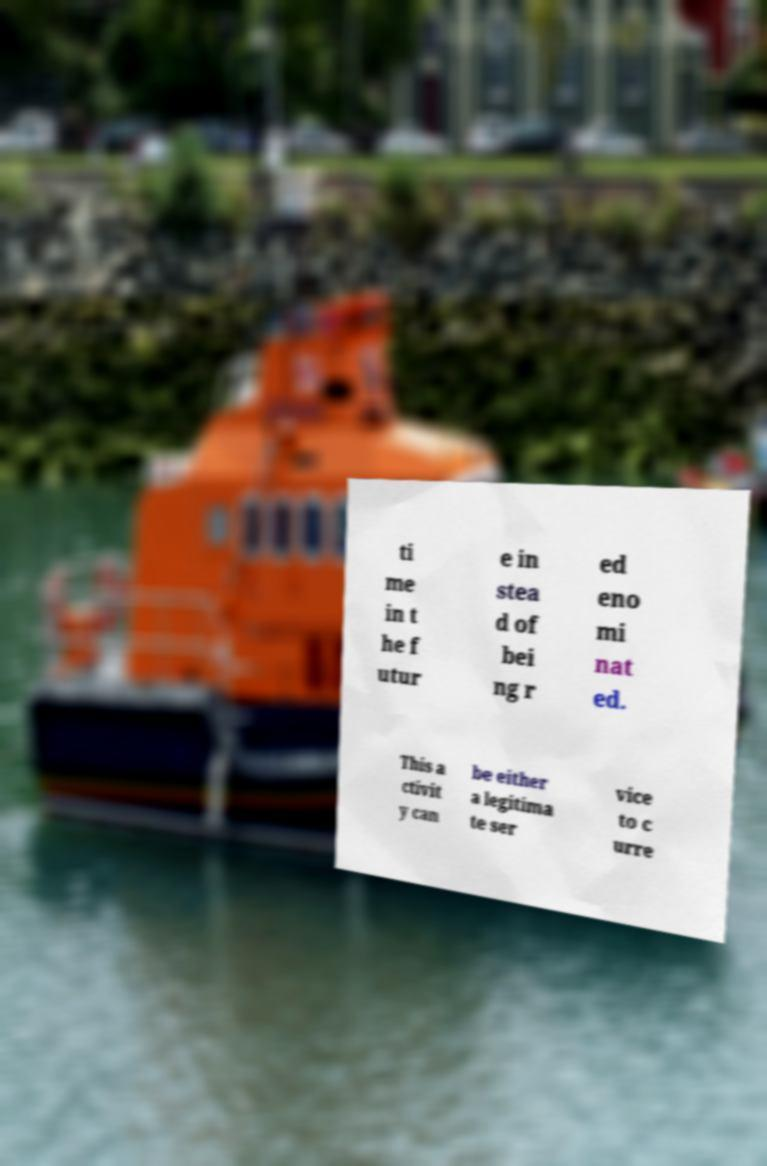Please read and relay the text visible in this image. What does it say? ti me in t he f utur e in stea d of bei ng r ed eno mi nat ed. This a ctivit y can be either a legitima te ser vice to c urre 